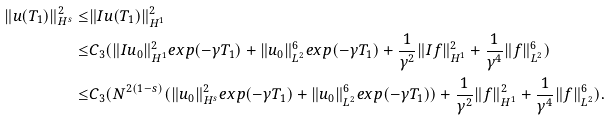Convert formula to latex. <formula><loc_0><loc_0><loc_500><loc_500>\| u ( T _ { 1 } ) \| _ { H ^ { s } } ^ { 2 } \leq & \| I u ( T _ { 1 } ) \| _ { H ^ { 1 } } ^ { 2 } \\ \leq & C _ { 3 } ( \| I u _ { 0 } \| ^ { 2 } _ { H ^ { 1 } } e x p ( - \gamma T _ { 1 } ) + \| u _ { 0 } \| ^ { 6 } _ { L ^ { 2 } } e x p ( - \gamma T _ { 1 } ) + \frac { 1 } { \gamma ^ { 2 } } \| I f \| ^ { 2 } _ { H ^ { 1 } } + \frac { 1 } { \gamma ^ { 4 } } \| f \| ^ { 6 } _ { L ^ { 2 } } ) \\ \leq & C _ { 3 } ( N ^ { 2 ( 1 - s ) } ( \| u _ { 0 } \| ^ { 2 } _ { H ^ { s } } e x p ( - \gamma T _ { 1 } ) + \| u _ { 0 } \| ^ { 6 } _ { L ^ { 2 } } e x p ( - \gamma T _ { 1 } ) ) + \frac { 1 } { \gamma ^ { 2 } } \| f \| ^ { 2 } _ { H ^ { 1 } } + \frac { 1 } { \gamma ^ { 4 } } \| f \| ^ { 6 } _ { L ^ { 2 } } ) .</formula> 